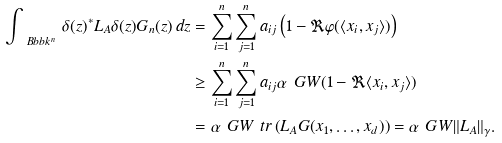Convert formula to latex. <formula><loc_0><loc_0><loc_500><loc_500>\int _ { \ B b b k ^ { n } } \, \delta ( z ) ^ { * } L _ { A } \delta ( z ) G _ { n } ( z ) \, d z & = \sum _ { i = 1 } ^ { n } \sum _ { j = 1 } ^ { n } a _ { i j } \left ( 1 - \Re \varphi ( \langle x _ { i } , x _ { j } \rangle ) \right ) \\ & \geq \sum _ { i = 1 } ^ { n } \sum _ { j = 1 } ^ { n } a _ { i j } \alpha _ { \ } G W ( 1 - \Re \langle x _ { i } , x _ { j } \rangle ) \\ & = \alpha _ { \ } G W \ t r \left ( L _ { A } G ( x _ { 1 } , \dots , x _ { d } ) \right ) = \alpha _ { \ } G W \| L _ { A } \| _ { \gamma } .</formula> 